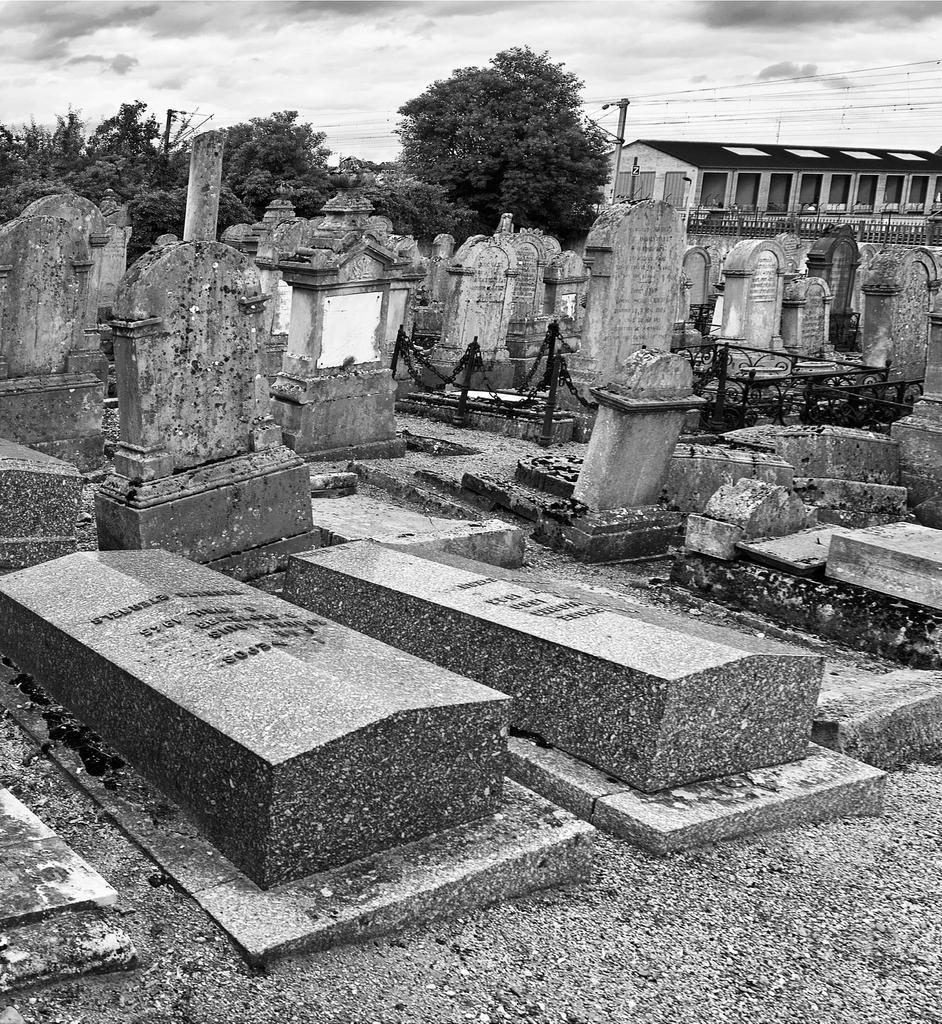Can you describe this image briefly? This is a black and white image and this place is a graveyard. In the background there are some trees and a building. At the top of the image I can see the sky. 